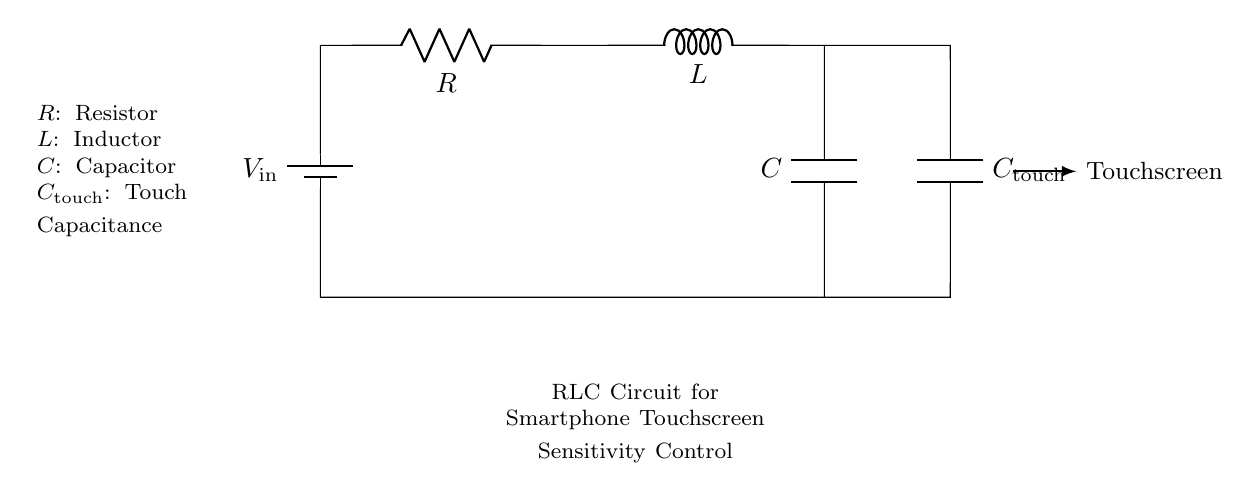What components are in the circuit? The circuit includes a resistor, an inductor, and two capacitors, one of which is designated as the touch capacitance.
Answer: Resistor, Inductor, Capacitors What is the function of the capacitor labeled "C_touch"? The capacitor labeled "C_touch" is specifically used for the touchscreen sensitivity, helping to improve the response by detecting touch.
Answer: Touch sensitivity How many capacitors are present in the circuit? There are two capacitors: one is part of the RLC circuit and the other is the one specifically designated for touch ("C_touch").
Answer: Two What is the role of the inductor in this circuit? The inductor works to store energy in the magnetic field and helps in managing the transient response of the circuit when a touch event is detected.
Answer: Energy storage What happens if the resistance "R" increases? Increasing resistance would reduce the overall current flow through the circuit, possibly affecting the sensitivity and responsiveness of the touchscreen.
Answer: Reduced current Why is the combination of resistor, inductor, and capacitors effective for touchscreen applications? The combination enables controlled damping and resonance, influencing how quickly the touchscreen responds to inputs while filtering noise.
Answer: Controlled damping and resonance 